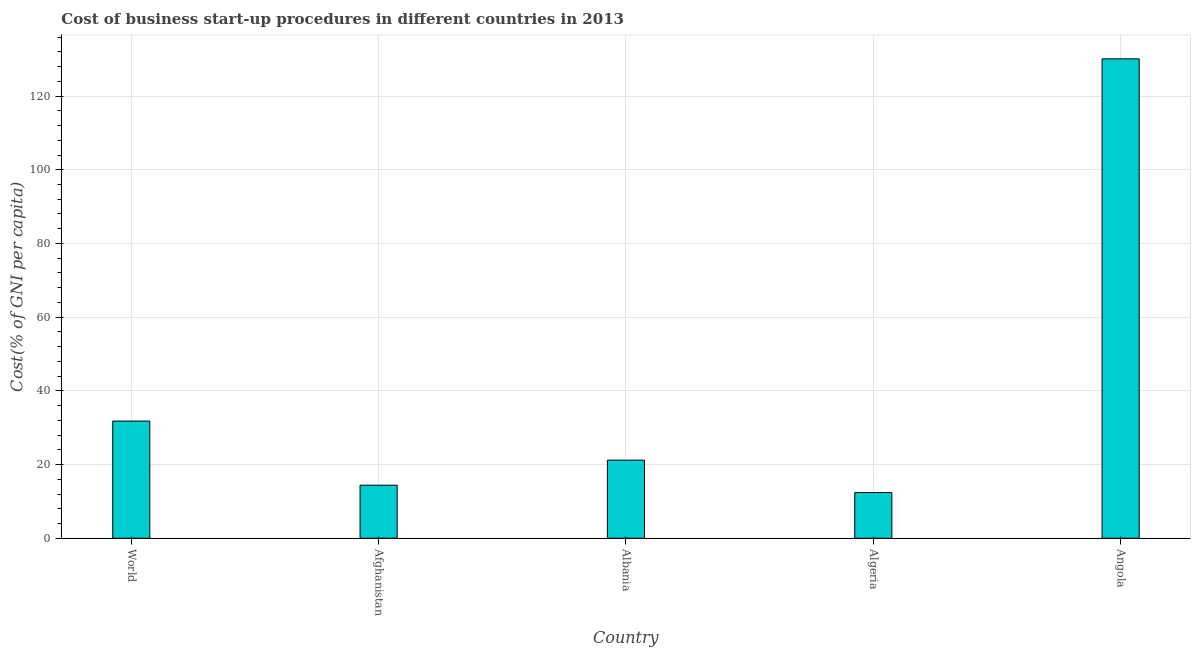What is the title of the graph?
Ensure brevity in your answer.  Cost of business start-up procedures in different countries in 2013. What is the label or title of the Y-axis?
Provide a succinct answer. Cost(% of GNI per capita). What is the cost of business startup procedures in Albania?
Keep it short and to the point. 21.2. Across all countries, what is the maximum cost of business startup procedures?
Ensure brevity in your answer.  130.1. Across all countries, what is the minimum cost of business startup procedures?
Your response must be concise. 12.4. In which country was the cost of business startup procedures maximum?
Keep it short and to the point. Angola. In which country was the cost of business startup procedures minimum?
Give a very brief answer. Algeria. What is the sum of the cost of business startup procedures?
Provide a short and direct response. 209.9. What is the difference between the cost of business startup procedures in Angola and World?
Provide a short and direct response. 98.3. What is the average cost of business startup procedures per country?
Offer a very short reply. 41.98. What is the median cost of business startup procedures?
Your answer should be compact. 21.2. What is the ratio of the cost of business startup procedures in Afghanistan to that in Angola?
Your answer should be very brief. 0.11. Is the cost of business startup procedures in Angola less than that in World?
Offer a terse response. No. What is the difference between the highest and the second highest cost of business startup procedures?
Your answer should be compact. 98.3. What is the difference between the highest and the lowest cost of business startup procedures?
Provide a short and direct response. 117.7. In how many countries, is the cost of business startup procedures greater than the average cost of business startup procedures taken over all countries?
Ensure brevity in your answer.  1. Are all the bars in the graph horizontal?
Provide a succinct answer. No. What is the difference between two consecutive major ticks on the Y-axis?
Keep it short and to the point. 20. What is the Cost(% of GNI per capita) of World?
Provide a short and direct response. 31.8. What is the Cost(% of GNI per capita) of Afghanistan?
Your response must be concise. 14.4. What is the Cost(% of GNI per capita) of Albania?
Ensure brevity in your answer.  21.2. What is the Cost(% of GNI per capita) in Algeria?
Make the answer very short. 12.4. What is the Cost(% of GNI per capita) of Angola?
Your answer should be very brief. 130.1. What is the difference between the Cost(% of GNI per capita) in World and Afghanistan?
Your answer should be very brief. 17.4. What is the difference between the Cost(% of GNI per capita) in World and Albania?
Your answer should be compact. 10.6. What is the difference between the Cost(% of GNI per capita) in World and Algeria?
Provide a succinct answer. 19.4. What is the difference between the Cost(% of GNI per capita) in World and Angola?
Make the answer very short. -98.3. What is the difference between the Cost(% of GNI per capita) in Afghanistan and Algeria?
Your answer should be compact. 2. What is the difference between the Cost(% of GNI per capita) in Afghanistan and Angola?
Provide a succinct answer. -115.7. What is the difference between the Cost(% of GNI per capita) in Albania and Algeria?
Keep it short and to the point. 8.8. What is the difference between the Cost(% of GNI per capita) in Albania and Angola?
Provide a succinct answer. -108.9. What is the difference between the Cost(% of GNI per capita) in Algeria and Angola?
Offer a terse response. -117.7. What is the ratio of the Cost(% of GNI per capita) in World to that in Afghanistan?
Provide a short and direct response. 2.21. What is the ratio of the Cost(% of GNI per capita) in World to that in Algeria?
Provide a short and direct response. 2.56. What is the ratio of the Cost(% of GNI per capita) in World to that in Angola?
Ensure brevity in your answer.  0.24. What is the ratio of the Cost(% of GNI per capita) in Afghanistan to that in Albania?
Your answer should be very brief. 0.68. What is the ratio of the Cost(% of GNI per capita) in Afghanistan to that in Algeria?
Ensure brevity in your answer.  1.16. What is the ratio of the Cost(% of GNI per capita) in Afghanistan to that in Angola?
Your answer should be very brief. 0.11. What is the ratio of the Cost(% of GNI per capita) in Albania to that in Algeria?
Offer a terse response. 1.71. What is the ratio of the Cost(% of GNI per capita) in Albania to that in Angola?
Offer a terse response. 0.16. What is the ratio of the Cost(% of GNI per capita) in Algeria to that in Angola?
Keep it short and to the point. 0.1. 